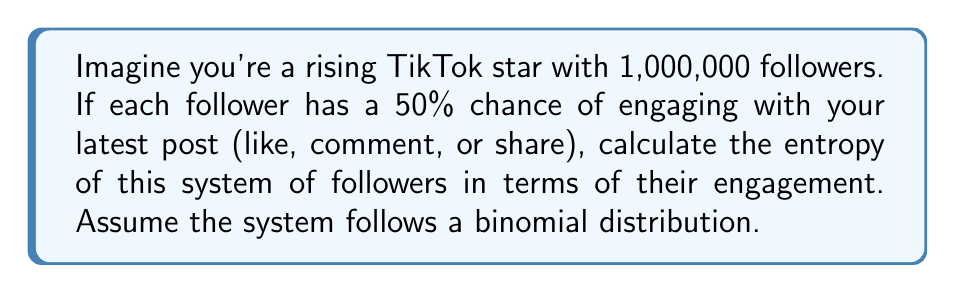Solve this math problem. Let's approach this step-by-step:

1) First, we need to understand that this system follows a binomial distribution with:
   $n = 1,000,000$ (total number of followers)
   $p = 0.5$ (probability of engagement)

2) For a binomial distribution, the entropy is given by:

   $$S = -n[p\ln p + (1-p)\ln(1-p)] + \frac{1}{2}\ln(2\pi np(1-p))$$

3) Let's substitute our values:

   $$S = -1,000,000[0.5\ln(0.5) + 0.5\ln(0.5)] + \frac{1}{2}\ln(2\pi \cdot 1,000,000 \cdot 0.5 \cdot 0.5)$$

4) Simplify the first part:
   $0.5\ln(0.5) \approx -0.34657359$
   So, $0.5\ln(0.5) + 0.5\ln(0.5) = -0.69314718$

   $$S = 693,147.18 + \frac{1}{2}\ln(785,398,163.4)$$

5) Calculate the second part:
   $\frac{1}{2}\ln(785,398,163.4) \approx 6.83$

6) Sum up the parts:

   $$S = 693,147.18 + 6.83 = 693,154.01$$

The units of entropy here are nats (natural units of information).
Answer: 693,154.01 nats 